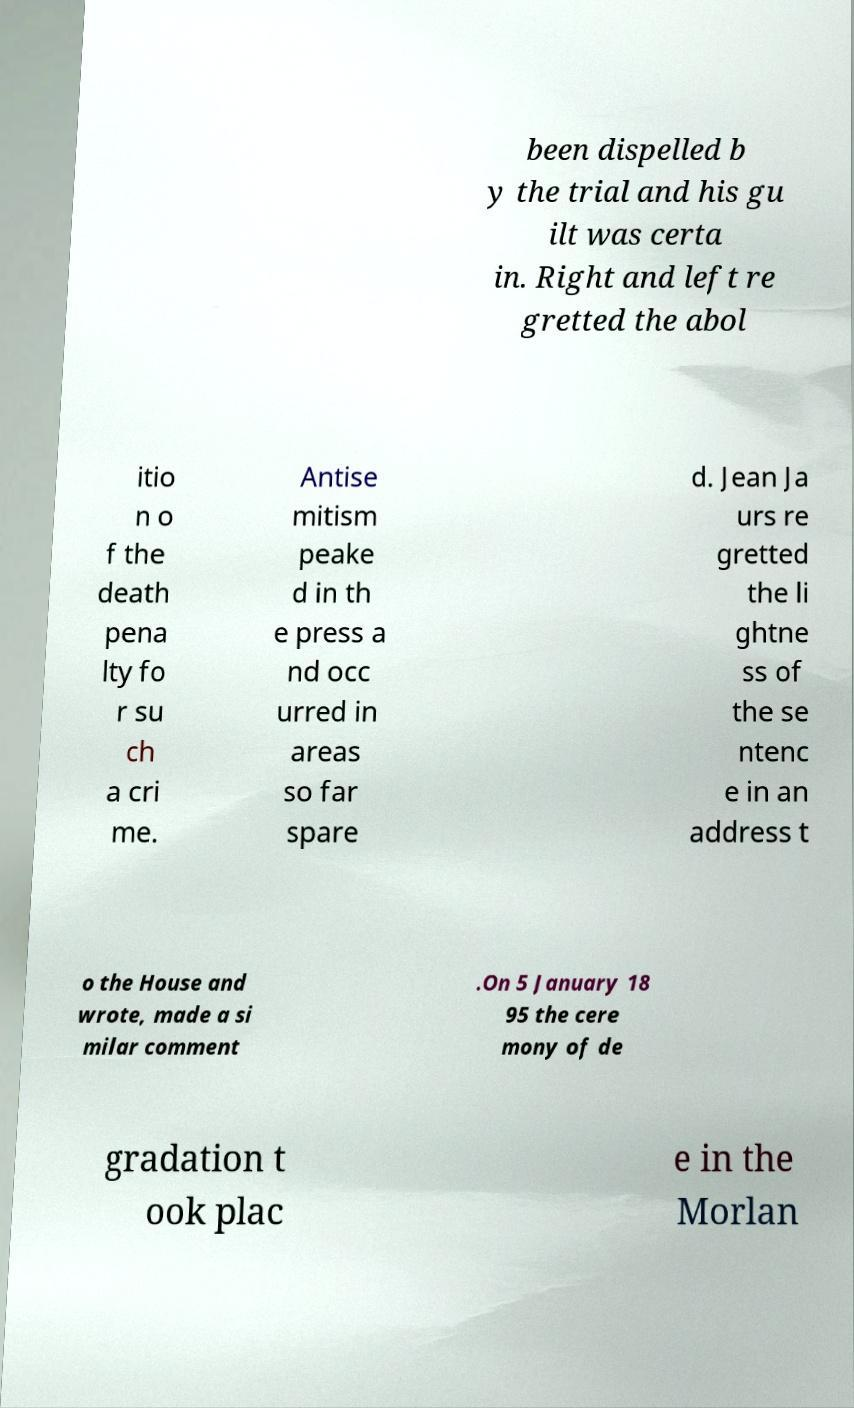Please read and relay the text visible in this image. What does it say? been dispelled b y the trial and his gu ilt was certa in. Right and left re gretted the abol itio n o f the death pena lty fo r su ch a cri me. Antise mitism peake d in th e press a nd occ urred in areas so far spare d. Jean Ja urs re gretted the li ghtne ss of the se ntenc e in an address t o the House and wrote, made a si milar comment .On 5 January 18 95 the cere mony of de gradation t ook plac e in the Morlan 